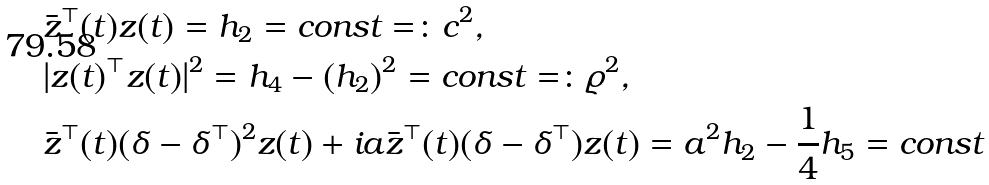Convert formula to latex. <formula><loc_0><loc_0><loc_500><loc_500>& \bar { z } ^ { \top } ( t ) z ( t ) = h _ { 2 } = c o n s t = \colon c ^ { 2 } , \\ & | z ( t ) ^ { \top } z ( t ) | ^ { 2 } = h _ { 4 } - ( h _ { 2 } ) ^ { 2 } = c o n s t = \colon \varrho ^ { 2 } , \\ & \bar { z } ^ { \top } ( t ) ( { \boldsymbol \delta } - { \boldsymbol \delta } ^ { \top } ) ^ { 2 } z ( t ) + i a \bar { z } ^ { \top } ( t ) ( { \boldsymbol \delta } - { \boldsymbol \delta } ^ { \top } ) z ( t ) = a ^ { 2 } h _ { 2 } - \frac { 1 } { 4 } h _ { 5 } = c o n s t</formula> 